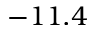Convert formula to latex. <formula><loc_0><loc_0><loc_500><loc_500>- 1 1 . 4</formula> 